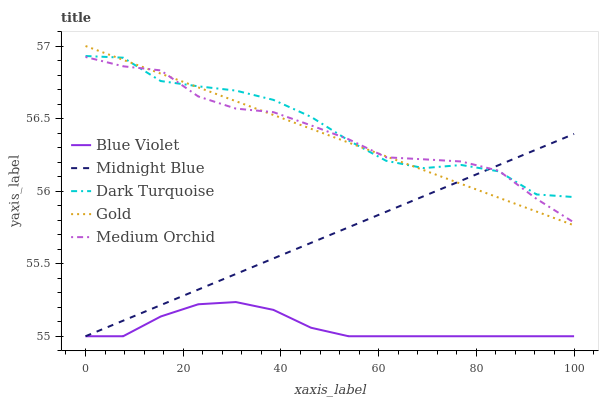Does Blue Violet have the minimum area under the curve?
Answer yes or no. Yes. Does Dark Turquoise have the maximum area under the curve?
Answer yes or no. Yes. Does Medium Orchid have the minimum area under the curve?
Answer yes or no. No. Does Medium Orchid have the maximum area under the curve?
Answer yes or no. No. Is Midnight Blue the smoothest?
Answer yes or no. Yes. Is Dark Turquoise the roughest?
Answer yes or no. Yes. Is Medium Orchid the smoothest?
Answer yes or no. No. Is Medium Orchid the roughest?
Answer yes or no. No. Does Midnight Blue have the lowest value?
Answer yes or no. Yes. Does Medium Orchid have the lowest value?
Answer yes or no. No. Does Gold have the highest value?
Answer yes or no. Yes. Does Medium Orchid have the highest value?
Answer yes or no. No. Is Blue Violet less than Dark Turquoise?
Answer yes or no. Yes. Is Dark Turquoise greater than Blue Violet?
Answer yes or no. Yes. Does Gold intersect Midnight Blue?
Answer yes or no. Yes. Is Gold less than Midnight Blue?
Answer yes or no. No. Is Gold greater than Midnight Blue?
Answer yes or no. No. Does Blue Violet intersect Dark Turquoise?
Answer yes or no. No. 